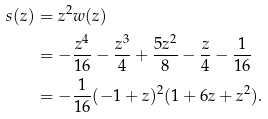Convert formula to latex. <formula><loc_0><loc_0><loc_500><loc_500>s ( z ) & = z ^ { 2 } w ( z ) \\ & = - \frac { z ^ { 4 } } { 1 6 } - \frac { z ^ { 3 } } { 4 } + \frac { 5 z ^ { 2 } } { 8 } - \frac { z } { 4 } - \frac { 1 } { 1 6 } \\ & = - \frac { 1 } { 1 6 } ( - 1 + z ) ^ { 2 } ( 1 + 6 z + z ^ { 2 } ) .</formula> 